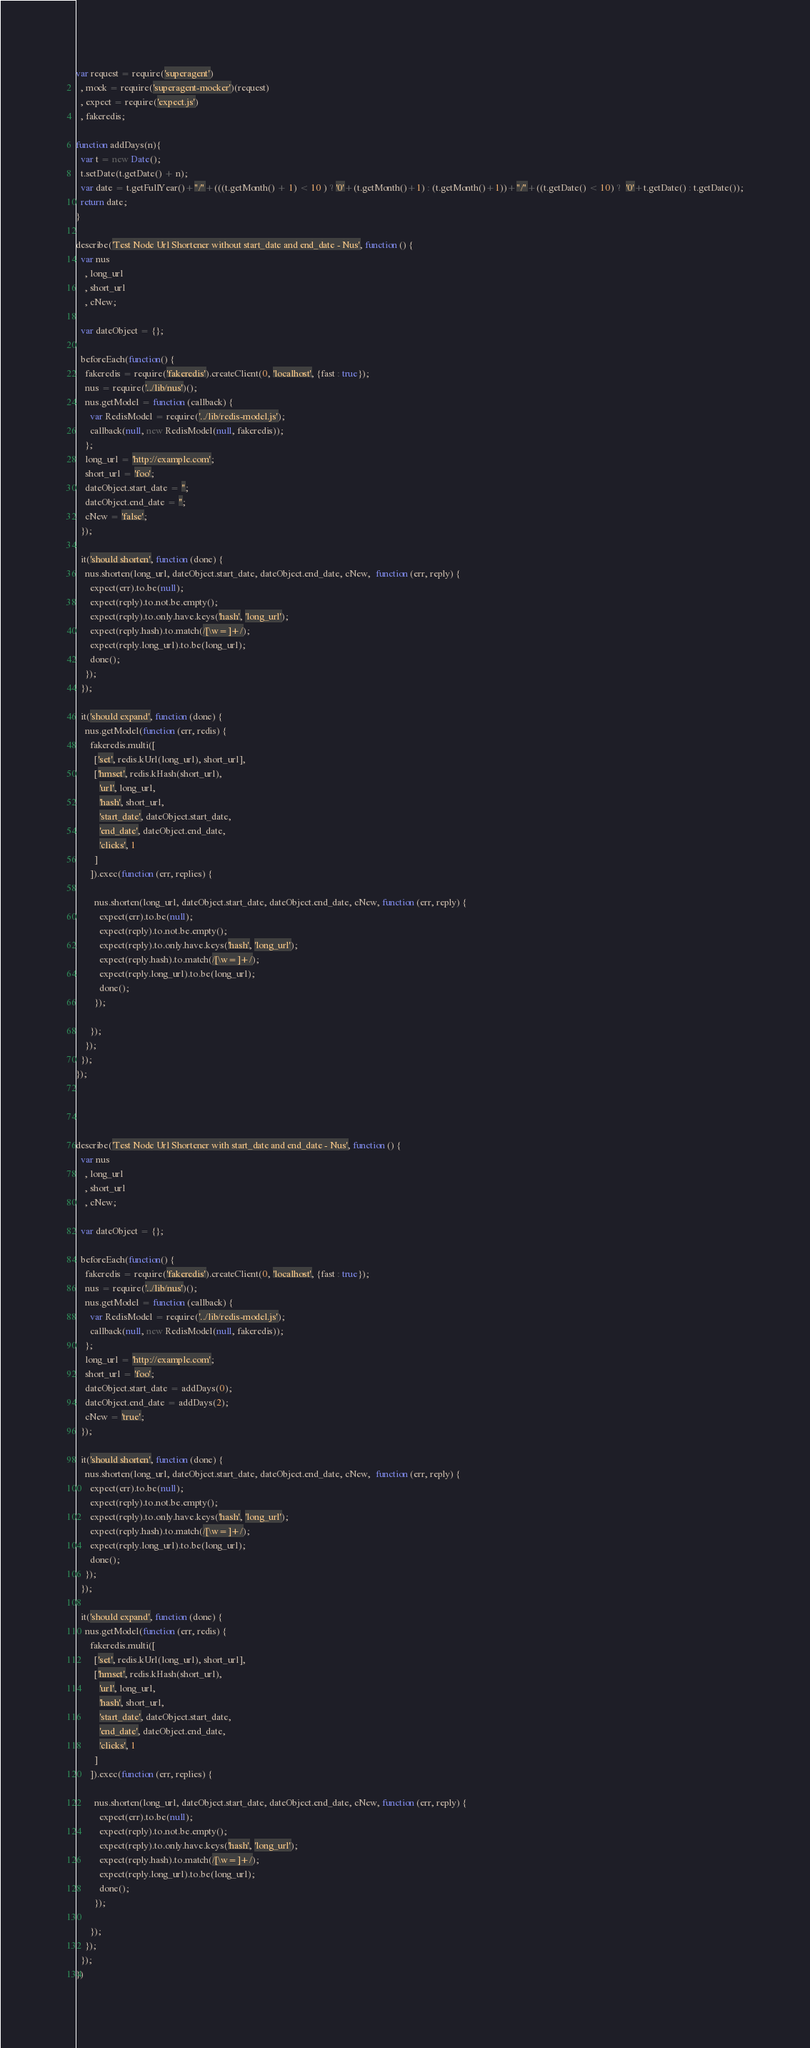Convert code to text. <code><loc_0><loc_0><loc_500><loc_500><_JavaScript_>var request = require('superagent')
  , mock = require('superagent-mocker')(request)
  , expect = require('expect.js')
  , fakeredis;

function addDays(n){
  var t = new Date();
  t.setDate(t.getDate() + n);
  var date = t.getFullYear()+"/"+(((t.getMonth() + 1) < 10 ) ? '0'+(t.getMonth()+1) : (t.getMonth()+1))+"/"+((t.getDate() < 10) ?  '0'+t.getDate() : t.getDate());
  return date;
}

describe('Test Node Url Shortener without start_date and end_date - Nus', function () {
  var nus
    , long_url
    , short_url
    , cNew;

  var dateObject = {};

  beforeEach(function() {
    fakeredis = require('fakeredis').createClient(0, 'localhost', {fast : true});
    nus = require('../lib/nus')();
    nus.getModel = function (callback) {
      var RedisModel = require('../lib/redis-model.js');
      callback(null, new RedisModel(null, fakeredis));
    };
    long_url = 'http://example.com';
    short_url = 'foo';
    dateObject.start_date = '';
    dateObject.end_date = '';
    cNew = 'false';
  });

  it('should shorten', function (done) {
    nus.shorten(long_url, dateObject.start_date, dateObject.end_date, cNew,  function (err, reply) {
      expect(err).to.be(null);
      expect(reply).to.not.be.empty();
      expect(reply).to.only.have.keys('hash', 'long_url');
      expect(reply.hash).to.match(/[\w=]+/);
      expect(reply.long_url).to.be(long_url);
      done();
    });
  });

  it('should expand', function (done) {
    nus.getModel(function (err, redis) {
      fakeredis.multi([
        ['set', redis.kUrl(long_url), short_url],
        ['hmset', redis.kHash(short_url),
          'url', long_url,
          'hash', short_url,
          'start_date', dateObject.start_date,
          'end_date', dateObject.end_date,
          'clicks', 1
        ]
      ]).exec(function (err, replies) {

        nus.shorten(long_url, dateObject.start_date, dateObject.end_date, cNew, function (err, reply) {
          expect(err).to.be(null);
          expect(reply).to.not.be.empty();
          expect(reply).to.only.have.keys('hash', 'long_url');
          expect(reply.hash).to.match(/[\w=]+/);
          expect(reply.long_url).to.be(long_url);
          done();
        });

      });
    });
  });
});




describe('Test Node Url Shortener with start_date and end_date - Nus', function () {
  var nus
    , long_url
    , short_url
    , cNew;

  var dateObject = {};

  beforeEach(function() {
    fakeredis = require('fakeredis').createClient(0, 'localhost', {fast : true});
    nus = require('../lib/nus')();
    nus.getModel = function (callback) {
      var RedisModel = require('../lib/redis-model.js');
      callback(null, new RedisModel(null, fakeredis));
    };
    long_url = 'http://example.com';
    short_url = 'foo';
    dateObject.start_date = addDays(0);
    dateObject.end_date = addDays(2);
    cNew = 'true';
  });

  it('should shorten', function (done) {
    nus.shorten(long_url, dateObject.start_date, dateObject.end_date, cNew,  function (err, reply) {
      expect(err).to.be(null);
      expect(reply).to.not.be.empty();
      expect(reply).to.only.have.keys('hash', 'long_url');
      expect(reply.hash).to.match(/[\w=]+/);
      expect(reply.long_url).to.be(long_url);
      done();
    });
  });

  it('should expand', function (done) {
    nus.getModel(function (err, redis) {
      fakeredis.multi([
        ['set', redis.kUrl(long_url), short_url],
        ['hmset', redis.kHash(short_url),
          'url', long_url,
          'hash', short_url,
          'start_date', dateObject.start_date,
          'end_date', dateObject.end_date,
          'clicks', 1
        ]
      ]).exec(function (err, replies) {

        nus.shorten(long_url, dateObject.start_date, dateObject.end_date, cNew, function (err, reply) {
          expect(err).to.be(null);
          expect(reply).to.not.be.empty();
          expect(reply).to.only.have.keys('hash', 'long_url');
          expect(reply.hash).to.match(/[\w=]+/);
          expect(reply.long_url).to.be(long_url);
          done();
        });

      });
    });
  });
})

</code> 